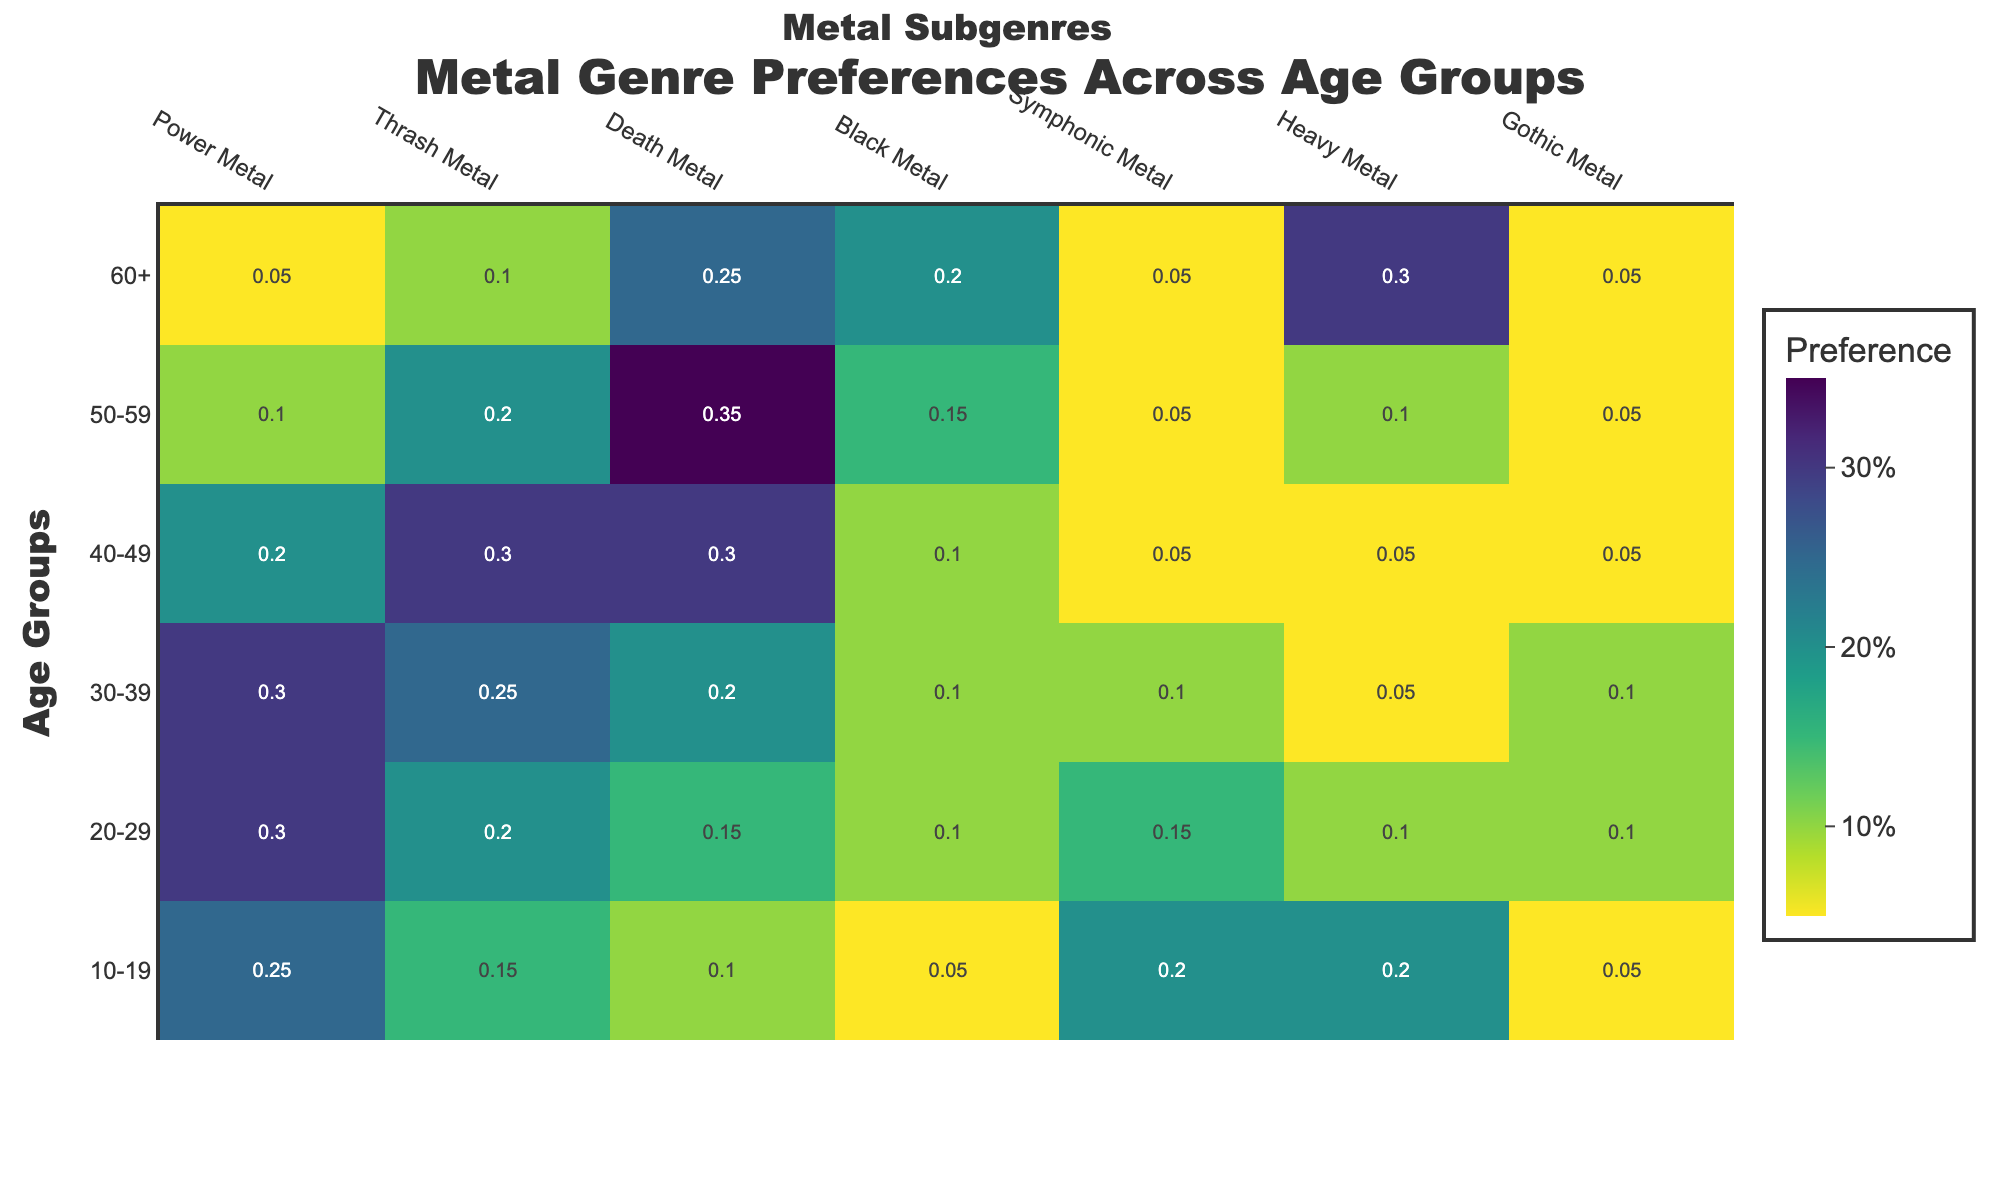What age group shows the highest preference for Power Metal? Look at the heatmap for the Power Metal genre and find the age group with the highest value. The highest value under Power Metal is 0.3, which is shown in the age groups 20-29 and 30-39.
Answer: 20-29, 30-39 Which genre is most preferred by the age group 50-59? Check the heatmap row corresponding to the 50-59 age group. The highest value in that row is 0.35, which corresponds to the Death Metal genre.
Answer: Death Metal What is the average preference for Black Metal across all age groups? Sum all the preference values for Black Metal and divide by the number of age groups. The sum is 0.05 + 0.1 + 0.1 + 0.1 + 0.15 + 0.2 = 0.7. The number of age groups is 6, so the average is 0.7 / 6 ≈ 0.117.
Answer: 0.117 Which genre shows an increasing preference trend with increasing age? Examine each genre column for values that increase as you move from the 10-19 age group to the 60+ age group. The genre that shows this trend is Heavy Metal (0.2, 0.1, 0.05, 0.05, 0.1, 0.3).
Answer: Heavy Metal In which age group is Symphonic Metal least preferred? Check the heatmap column for Symphonic Metal to find the lowest value. The lowest value is 0.05, which appears in the age groups 40-49, 50-59, and 60+.
Answer: 40-49, 50-59, 60+ Are there any genres that are more preferred by younger listeners (10-29) compared to older listeners (30+)? Compare the preference values of each genre between younger listeners (10-19, 20-29) and older listeners (30-39, 40-49, 50-59, 60+). Power Metal values are higher for younger (0.25, 0.3) than older (0.3, 0.2, 0.1, 0.05). Symphonic Metal is also more preferred by younger listeners (0.2, 0.15) than older listeners (0.1, 0.05, 0.05, 0.05).
Answer: Power Metal, Symphonic Metal Which age group has the most varied music genre preferences? To find the age group with the most varied preferences, look at the age group row with the highest range of values. The age group 20-29 has preferences ranging from 0.1 to 0.3, which is the widest range.
Answer: 20-29 What is the combined preference for Gothic Metal and Heavy Metal in the age group 30-39? Add the preference values for Gothic Metal and Heavy Metal in the 30-39 age group. The values are 0.1 for Gothic Metal and 0.05 for Heavy Metal. So, the combined preference is 0.1 + 0.05 = 0.15.
Answer: 0.15 